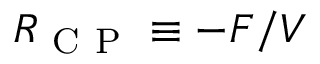Convert formula to latex. <formula><loc_0><loc_0><loc_500><loc_500>R _ { C P } \equiv - F / V</formula> 